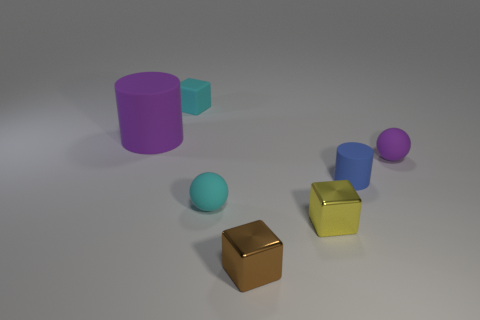Are there any other things of the same color as the small rubber cylinder? The small rubber cylinder is a unique shade of teal that does not appear on any other objects in this image. However, the larger cylinder, although a different color, shares a similar matte finish. 